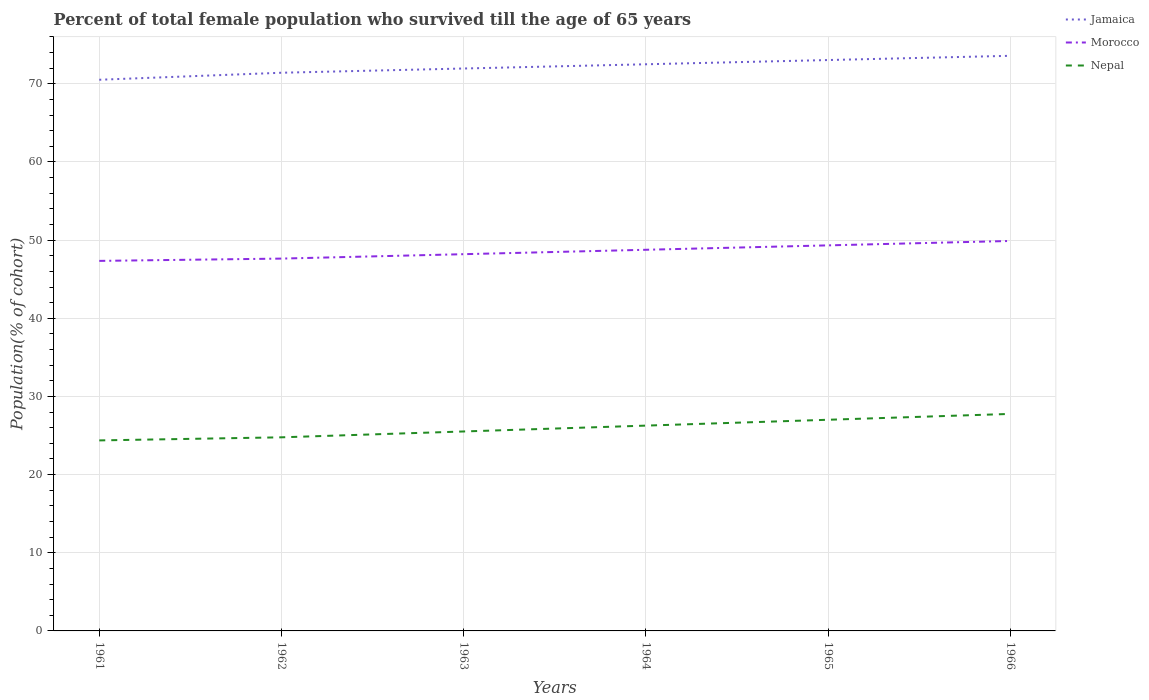How many different coloured lines are there?
Keep it short and to the point. 3. Across all years, what is the maximum percentage of total female population who survived till the age of 65 years in Jamaica?
Your answer should be compact. 70.52. What is the total percentage of total female population who survived till the age of 65 years in Nepal in the graph?
Your answer should be very brief. -0.75. What is the difference between the highest and the second highest percentage of total female population who survived till the age of 65 years in Jamaica?
Keep it short and to the point. 3.06. Is the percentage of total female population who survived till the age of 65 years in Nepal strictly greater than the percentage of total female population who survived till the age of 65 years in Morocco over the years?
Ensure brevity in your answer.  Yes. How many lines are there?
Offer a very short reply. 3. What is the difference between two consecutive major ticks on the Y-axis?
Ensure brevity in your answer.  10. Are the values on the major ticks of Y-axis written in scientific E-notation?
Your response must be concise. No. Does the graph contain any zero values?
Make the answer very short. No. Where does the legend appear in the graph?
Provide a short and direct response. Top right. What is the title of the graph?
Your answer should be very brief. Percent of total female population who survived till the age of 65 years. What is the label or title of the X-axis?
Your answer should be compact. Years. What is the label or title of the Y-axis?
Your answer should be very brief. Population(% of cohort). What is the Population(% of cohort) in Jamaica in 1961?
Give a very brief answer. 70.52. What is the Population(% of cohort) in Morocco in 1961?
Your response must be concise. 47.34. What is the Population(% of cohort) in Nepal in 1961?
Your response must be concise. 24.38. What is the Population(% of cohort) of Jamaica in 1962?
Ensure brevity in your answer.  71.42. What is the Population(% of cohort) of Morocco in 1962?
Offer a very short reply. 47.64. What is the Population(% of cohort) of Nepal in 1962?
Your answer should be compact. 24.77. What is the Population(% of cohort) in Jamaica in 1963?
Provide a short and direct response. 71.96. What is the Population(% of cohort) in Morocco in 1963?
Make the answer very short. 48.2. What is the Population(% of cohort) of Nepal in 1963?
Your answer should be very brief. 25.52. What is the Population(% of cohort) of Jamaica in 1964?
Provide a succinct answer. 72.5. What is the Population(% of cohort) in Morocco in 1964?
Offer a very short reply. 48.77. What is the Population(% of cohort) of Nepal in 1964?
Ensure brevity in your answer.  26.27. What is the Population(% of cohort) in Jamaica in 1965?
Ensure brevity in your answer.  73.04. What is the Population(% of cohort) in Morocco in 1965?
Offer a terse response. 49.33. What is the Population(% of cohort) in Nepal in 1965?
Provide a short and direct response. 27.02. What is the Population(% of cohort) in Jamaica in 1966?
Offer a very short reply. 73.59. What is the Population(% of cohort) of Morocco in 1966?
Provide a short and direct response. 49.9. What is the Population(% of cohort) of Nepal in 1966?
Make the answer very short. 27.77. Across all years, what is the maximum Population(% of cohort) in Jamaica?
Give a very brief answer. 73.59. Across all years, what is the maximum Population(% of cohort) in Morocco?
Offer a terse response. 49.9. Across all years, what is the maximum Population(% of cohort) of Nepal?
Keep it short and to the point. 27.77. Across all years, what is the minimum Population(% of cohort) in Jamaica?
Your answer should be compact. 70.52. Across all years, what is the minimum Population(% of cohort) of Morocco?
Make the answer very short. 47.34. Across all years, what is the minimum Population(% of cohort) in Nepal?
Provide a short and direct response. 24.38. What is the total Population(% of cohort) of Jamaica in the graph?
Provide a short and direct response. 433.03. What is the total Population(% of cohort) of Morocco in the graph?
Keep it short and to the point. 291.18. What is the total Population(% of cohort) in Nepal in the graph?
Your answer should be compact. 155.72. What is the difference between the Population(% of cohort) of Jamaica in 1961 and that in 1962?
Ensure brevity in your answer.  -0.9. What is the difference between the Population(% of cohort) in Morocco in 1961 and that in 1962?
Your answer should be very brief. -0.29. What is the difference between the Population(% of cohort) in Nepal in 1961 and that in 1962?
Your answer should be very brief. -0.39. What is the difference between the Population(% of cohort) of Jamaica in 1961 and that in 1963?
Your response must be concise. -1.44. What is the difference between the Population(% of cohort) of Morocco in 1961 and that in 1963?
Offer a very short reply. -0.86. What is the difference between the Population(% of cohort) in Nepal in 1961 and that in 1963?
Offer a very short reply. -1.14. What is the difference between the Population(% of cohort) in Jamaica in 1961 and that in 1964?
Provide a succinct answer. -1.98. What is the difference between the Population(% of cohort) of Morocco in 1961 and that in 1964?
Make the answer very short. -1.42. What is the difference between the Population(% of cohort) of Nepal in 1961 and that in 1964?
Ensure brevity in your answer.  -1.89. What is the difference between the Population(% of cohort) in Jamaica in 1961 and that in 1965?
Your answer should be very brief. -2.52. What is the difference between the Population(% of cohort) in Morocco in 1961 and that in 1965?
Offer a very short reply. -1.99. What is the difference between the Population(% of cohort) of Nepal in 1961 and that in 1965?
Give a very brief answer. -2.64. What is the difference between the Population(% of cohort) of Jamaica in 1961 and that in 1966?
Offer a terse response. -3.06. What is the difference between the Population(% of cohort) in Morocco in 1961 and that in 1966?
Offer a very short reply. -2.55. What is the difference between the Population(% of cohort) of Nepal in 1961 and that in 1966?
Offer a terse response. -3.39. What is the difference between the Population(% of cohort) of Jamaica in 1962 and that in 1963?
Your answer should be very brief. -0.54. What is the difference between the Population(% of cohort) of Morocco in 1962 and that in 1963?
Provide a short and direct response. -0.56. What is the difference between the Population(% of cohort) in Nepal in 1962 and that in 1963?
Your response must be concise. -0.75. What is the difference between the Population(% of cohort) of Jamaica in 1962 and that in 1964?
Your answer should be very brief. -1.08. What is the difference between the Population(% of cohort) of Morocco in 1962 and that in 1964?
Provide a short and direct response. -1.13. What is the difference between the Population(% of cohort) of Nepal in 1962 and that in 1964?
Make the answer very short. -1.5. What is the difference between the Population(% of cohort) of Jamaica in 1962 and that in 1965?
Offer a terse response. -1.63. What is the difference between the Population(% of cohort) of Morocco in 1962 and that in 1965?
Your answer should be very brief. -1.69. What is the difference between the Population(% of cohort) in Nepal in 1962 and that in 1965?
Provide a short and direct response. -2.25. What is the difference between the Population(% of cohort) in Jamaica in 1962 and that in 1966?
Offer a terse response. -2.17. What is the difference between the Population(% of cohort) of Morocco in 1962 and that in 1966?
Give a very brief answer. -2.26. What is the difference between the Population(% of cohort) in Nepal in 1962 and that in 1966?
Keep it short and to the point. -3. What is the difference between the Population(% of cohort) of Jamaica in 1963 and that in 1964?
Offer a very short reply. -0.54. What is the difference between the Population(% of cohort) of Morocco in 1963 and that in 1964?
Your answer should be very brief. -0.56. What is the difference between the Population(% of cohort) of Nepal in 1963 and that in 1964?
Provide a succinct answer. -0.75. What is the difference between the Population(% of cohort) in Jamaica in 1963 and that in 1965?
Provide a succinct answer. -1.08. What is the difference between the Population(% of cohort) of Morocco in 1963 and that in 1965?
Offer a very short reply. -1.13. What is the difference between the Population(% of cohort) of Nepal in 1963 and that in 1965?
Keep it short and to the point. -1.5. What is the difference between the Population(% of cohort) of Jamaica in 1963 and that in 1966?
Offer a terse response. -1.63. What is the difference between the Population(% of cohort) of Morocco in 1963 and that in 1966?
Give a very brief answer. -1.69. What is the difference between the Population(% of cohort) of Nepal in 1963 and that in 1966?
Your response must be concise. -2.25. What is the difference between the Population(% of cohort) in Jamaica in 1964 and that in 1965?
Keep it short and to the point. -0.54. What is the difference between the Population(% of cohort) in Morocco in 1964 and that in 1965?
Provide a succinct answer. -0.56. What is the difference between the Population(% of cohort) of Nepal in 1964 and that in 1965?
Offer a terse response. -0.75. What is the difference between the Population(% of cohort) in Jamaica in 1964 and that in 1966?
Give a very brief answer. -1.08. What is the difference between the Population(% of cohort) of Morocco in 1964 and that in 1966?
Your answer should be very brief. -1.13. What is the difference between the Population(% of cohort) of Nepal in 1964 and that in 1966?
Provide a succinct answer. -1.5. What is the difference between the Population(% of cohort) in Jamaica in 1965 and that in 1966?
Give a very brief answer. -0.54. What is the difference between the Population(% of cohort) of Morocco in 1965 and that in 1966?
Give a very brief answer. -0.56. What is the difference between the Population(% of cohort) in Nepal in 1965 and that in 1966?
Give a very brief answer. -0.75. What is the difference between the Population(% of cohort) of Jamaica in 1961 and the Population(% of cohort) of Morocco in 1962?
Your answer should be compact. 22.88. What is the difference between the Population(% of cohort) in Jamaica in 1961 and the Population(% of cohort) in Nepal in 1962?
Provide a succinct answer. 45.75. What is the difference between the Population(% of cohort) in Morocco in 1961 and the Population(% of cohort) in Nepal in 1962?
Provide a short and direct response. 22.57. What is the difference between the Population(% of cohort) of Jamaica in 1961 and the Population(% of cohort) of Morocco in 1963?
Keep it short and to the point. 22.32. What is the difference between the Population(% of cohort) in Jamaica in 1961 and the Population(% of cohort) in Nepal in 1963?
Keep it short and to the point. 45. What is the difference between the Population(% of cohort) in Morocco in 1961 and the Population(% of cohort) in Nepal in 1963?
Offer a very short reply. 21.82. What is the difference between the Population(% of cohort) in Jamaica in 1961 and the Population(% of cohort) in Morocco in 1964?
Give a very brief answer. 21.75. What is the difference between the Population(% of cohort) in Jamaica in 1961 and the Population(% of cohort) in Nepal in 1964?
Your answer should be compact. 44.25. What is the difference between the Population(% of cohort) in Morocco in 1961 and the Population(% of cohort) in Nepal in 1964?
Give a very brief answer. 21.08. What is the difference between the Population(% of cohort) in Jamaica in 1961 and the Population(% of cohort) in Morocco in 1965?
Your answer should be very brief. 21.19. What is the difference between the Population(% of cohort) in Jamaica in 1961 and the Population(% of cohort) in Nepal in 1965?
Your answer should be very brief. 43.5. What is the difference between the Population(% of cohort) in Morocco in 1961 and the Population(% of cohort) in Nepal in 1965?
Your response must be concise. 20.33. What is the difference between the Population(% of cohort) of Jamaica in 1961 and the Population(% of cohort) of Morocco in 1966?
Your answer should be very brief. 20.63. What is the difference between the Population(% of cohort) in Jamaica in 1961 and the Population(% of cohort) in Nepal in 1966?
Ensure brevity in your answer.  42.75. What is the difference between the Population(% of cohort) of Morocco in 1961 and the Population(% of cohort) of Nepal in 1966?
Ensure brevity in your answer.  19.58. What is the difference between the Population(% of cohort) of Jamaica in 1962 and the Population(% of cohort) of Morocco in 1963?
Keep it short and to the point. 23.21. What is the difference between the Population(% of cohort) of Jamaica in 1962 and the Population(% of cohort) of Nepal in 1963?
Provide a succinct answer. 45.9. What is the difference between the Population(% of cohort) in Morocco in 1962 and the Population(% of cohort) in Nepal in 1963?
Your response must be concise. 22.12. What is the difference between the Population(% of cohort) in Jamaica in 1962 and the Population(% of cohort) in Morocco in 1964?
Your answer should be very brief. 22.65. What is the difference between the Population(% of cohort) of Jamaica in 1962 and the Population(% of cohort) of Nepal in 1964?
Your response must be concise. 45.15. What is the difference between the Population(% of cohort) of Morocco in 1962 and the Population(% of cohort) of Nepal in 1964?
Provide a succinct answer. 21.37. What is the difference between the Population(% of cohort) in Jamaica in 1962 and the Population(% of cohort) in Morocco in 1965?
Provide a succinct answer. 22.09. What is the difference between the Population(% of cohort) of Jamaica in 1962 and the Population(% of cohort) of Nepal in 1965?
Ensure brevity in your answer.  44.4. What is the difference between the Population(% of cohort) of Morocco in 1962 and the Population(% of cohort) of Nepal in 1965?
Give a very brief answer. 20.62. What is the difference between the Population(% of cohort) in Jamaica in 1962 and the Population(% of cohort) in Morocco in 1966?
Offer a very short reply. 21.52. What is the difference between the Population(% of cohort) of Jamaica in 1962 and the Population(% of cohort) of Nepal in 1966?
Ensure brevity in your answer.  43.65. What is the difference between the Population(% of cohort) of Morocco in 1962 and the Population(% of cohort) of Nepal in 1966?
Provide a succinct answer. 19.87. What is the difference between the Population(% of cohort) in Jamaica in 1963 and the Population(% of cohort) in Morocco in 1964?
Offer a terse response. 23.19. What is the difference between the Population(% of cohort) in Jamaica in 1963 and the Population(% of cohort) in Nepal in 1964?
Ensure brevity in your answer.  45.69. What is the difference between the Population(% of cohort) of Morocco in 1963 and the Population(% of cohort) of Nepal in 1964?
Give a very brief answer. 21.93. What is the difference between the Population(% of cohort) of Jamaica in 1963 and the Population(% of cohort) of Morocco in 1965?
Keep it short and to the point. 22.63. What is the difference between the Population(% of cohort) of Jamaica in 1963 and the Population(% of cohort) of Nepal in 1965?
Offer a terse response. 44.94. What is the difference between the Population(% of cohort) of Morocco in 1963 and the Population(% of cohort) of Nepal in 1965?
Provide a succinct answer. 21.19. What is the difference between the Population(% of cohort) in Jamaica in 1963 and the Population(% of cohort) in Morocco in 1966?
Offer a very short reply. 22.07. What is the difference between the Population(% of cohort) of Jamaica in 1963 and the Population(% of cohort) of Nepal in 1966?
Offer a very short reply. 44.19. What is the difference between the Population(% of cohort) in Morocco in 1963 and the Population(% of cohort) in Nepal in 1966?
Your answer should be very brief. 20.44. What is the difference between the Population(% of cohort) in Jamaica in 1964 and the Population(% of cohort) in Morocco in 1965?
Your answer should be compact. 23.17. What is the difference between the Population(% of cohort) of Jamaica in 1964 and the Population(% of cohort) of Nepal in 1965?
Make the answer very short. 45.48. What is the difference between the Population(% of cohort) of Morocco in 1964 and the Population(% of cohort) of Nepal in 1965?
Give a very brief answer. 21.75. What is the difference between the Population(% of cohort) of Jamaica in 1964 and the Population(% of cohort) of Morocco in 1966?
Keep it short and to the point. 22.61. What is the difference between the Population(% of cohort) of Jamaica in 1964 and the Population(% of cohort) of Nepal in 1966?
Give a very brief answer. 44.74. What is the difference between the Population(% of cohort) in Morocco in 1964 and the Population(% of cohort) in Nepal in 1966?
Make the answer very short. 21. What is the difference between the Population(% of cohort) of Jamaica in 1965 and the Population(% of cohort) of Morocco in 1966?
Your answer should be very brief. 23.15. What is the difference between the Population(% of cohort) in Jamaica in 1965 and the Population(% of cohort) in Nepal in 1966?
Your answer should be compact. 45.28. What is the difference between the Population(% of cohort) of Morocco in 1965 and the Population(% of cohort) of Nepal in 1966?
Make the answer very short. 21.57. What is the average Population(% of cohort) of Jamaica per year?
Give a very brief answer. 72.17. What is the average Population(% of cohort) of Morocco per year?
Your answer should be compact. 48.53. What is the average Population(% of cohort) in Nepal per year?
Your response must be concise. 25.95. In the year 1961, what is the difference between the Population(% of cohort) of Jamaica and Population(% of cohort) of Morocco?
Provide a short and direct response. 23.18. In the year 1961, what is the difference between the Population(% of cohort) of Jamaica and Population(% of cohort) of Nepal?
Make the answer very short. 46.14. In the year 1961, what is the difference between the Population(% of cohort) of Morocco and Population(% of cohort) of Nepal?
Your response must be concise. 22.97. In the year 1962, what is the difference between the Population(% of cohort) of Jamaica and Population(% of cohort) of Morocco?
Provide a succinct answer. 23.78. In the year 1962, what is the difference between the Population(% of cohort) in Jamaica and Population(% of cohort) in Nepal?
Keep it short and to the point. 46.65. In the year 1962, what is the difference between the Population(% of cohort) in Morocco and Population(% of cohort) in Nepal?
Your response must be concise. 22.87. In the year 1963, what is the difference between the Population(% of cohort) of Jamaica and Population(% of cohort) of Morocco?
Your answer should be very brief. 23.76. In the year 1963, what is the difference between the Population(% of cohort) in Jamaica and Population(% of cohort) in Nepal?
Offer a terse response. 46.44. In the year 1963, what is the difference between the Population(% of cohort) of Morocco and Population(% of cohort) of Nepal?
Provide a succinct answer. 22.68. In the year 1964, what is the difference between the Population(% of cohort) of Jamaica and Population(% of cohort) of Morocco?
Provide a succinct answer. 23.73. In the year 1964, what is the difference between the Population(% of cohort) of Jamaica and Population(% of cohort) of Nepal?
Your answer should be very brief. 46.23. In the year 1964, what is the difference between the Population(% of cohort) of Morocco and Population(% of cohort) of Nepal?
Provide a short and direct response. 22.5. In the year 1965, what is the difference between the Population(% of cohort) of Jamaica and Population(% of cohort) of Morocco?
Make the answer very short. 23.71. In the year 1965, what is the difference between the Population(% of cohort) of Jamaica and Population(% of cohort) of Nepal?
Your answer should be compact. 46.03. In the year 1965, what is the difference between the Population(% of cohort) of Morocco and Population(% of cohort) of Nepal?
Provide a succinct answer. 22.31. In the year 1966, what is the difference between the Population(% of cohort) in Jamaica and Population(% of cohort) in Morocco?
Offer a terse response. 23.69. In the year 1966, what is the difference between the Population(% of cohort) of Jamaica and Population(% of cohort) of Nepal?
Your response must be concise. 45.82. In the year 1966, what is the difference between the Population(% of cohort) in Morocco and Population(% of cohort) in Nepal?
Provide a succinct answer. 22.13. What is the ratio of the Population(% of cohort) of Jamaica in 1961 to that in 1962?
Offer a terse response. 0.99. What is the ratio of the Population(% of cohort) in Morocco in 1961 to that in 1962?
Provide a short and direct response. 0.99. What is the ratio of the Population(% of cohort) in Nepal in 1961 to that in 1962?
Make the answer very short. 0.98. What is the ratio of the Population(% of cohort) in Jamaica in 1961 to that in 1963?
Your answer should be very brief. 0.98. What is the ratio of the Population(% of cohort) of Morocco in 1961 to that in 1963?
Provide a short and direct response. 0.98. What is the ratio of the Population(% of cohort) in Nepal in 1961 to that in 1963?
Give a very brief answer. 0.96. What is the ratio of the Population(% of cohort) of Jamaica in 1961 to that in 1964?
Your answer should be compact. 0.97. What is the ratio of the Population(% of cohort) in Morocco in 1961 to that in 1964?
Provide a succinct answer. 0.97. What is the ratio of the Population(% of cohort) in Nepal in 1961 to that in 1964?
Your answer should be compact. 0.93. What is the ratio of the Population(% of cohort) of Jamaica in 1961 to that in 1965?
Make the answer very short. 0.97. What is the ratio of the Population(% of cohort) of Morocco in 1961 to that in 1965?
Your answer should be compact. 0.96. What is the ratio of the Population(% of cohort) in Nepal in 1961 to that in 1965?
Make the answer very short. 0.9. What is the ratio of the Population(% of cohort) in Jamaica in 1961 to that in 1966?
Your response must be concise. 0.96. What is the ratio of the Population(% of cohort) in Morocco in 1961 to that in 1966?
Give a very brief answer. 0.95. What is the ratio of the Population(% of cohort) of Nepal in 1961 to that in 1966?
Your response must be concise. 0.88. What is the ratio of the Population(% of cohort) in Morocco in 1962 to that in 1963?
Your answer should be compact. 0.99. What is the ratio of the Population(% of cohort) in Nepal in 1962 to that in 1963?
Your answer should be compact. 0.97. What is the ratio of the Population(% of cohort) in Jamaica in 1962 to that in 1964?
Make the answer very short. 0.99. What is the ratio of the Population(% of cohort) in Morocco in 1962 to that in 1964?
Make the answer very short. 0.98. What is the ratio of the Population(% of cohort) in Nepal in 1962 to that in 1964?
Offer a very short reply. 0.94. What is the ratio of the Population(% of cohort) of Jamaica in 1962 to that in 1965?
Give a very brief answer. 0.98. What is the ratio of the Population(% of cohort) in Morocco in 1962 to that in 1965?
Your answer should be compact. 0.97. What is the ratio of the Population(% of cohort) in Nepal in 1962 to that in 1965?
Offer a terse response. 0.92. What is the ratio of the Population(% of cohort) of Jamaica in 1962 to that in 1966?
Your response must be concise. 0.97. What is the ratio of the Population(% of cohort) in Morocco in 1962 to that in 1966?
Your answer should be very brief. 0.95. What is the ratio of the Population(% of cohort) in Nepal in 1962 to that in 1966?
Your answer should be very brief. 0.89. What is the ratio of the Population(% of cohort) of Morocco in 1963 to that in 1964?
Offer a very short reply. 0.99. What is the ratio of the Population(% of cohort) in Nepal in 1963 to that in 1964?
Ensure brevity in your answer.  0.97. What is the ratio of the Population(% of cohort) of Jamaica in 1963 to that in 1965?
Your answer should be compact. 0.99. What is the ratio of the Population(% of cohort) of Morocco in 1963 to that in 1965?
Offer a terse response. 0.98. What is the ratio of the Population(% of cohort) in Nepal in 1963 to that in 1965?
Your response must be concise. 0.94. What is the ratio of the Population(% of cohort) in Jamaica in 1963 to that in 1966?
Your answer should be very brief. 0.98. What is the ratio of the Population(% of cohort) in Morocco in 1963 to that in 1966?
Make the answer very short. 0.97. What is the ratio of the Population(% of cohort) in Nepal in 1963 to that in 1966?
Offer a terse response. 0.92. What is the ratio of the Population(% of cohort) of Morocco in 1964 to that in 1965?
Your response must be concise. 0.99. What is the ratio of the Population(% of cohort) of Nepal in 1964 to that in 1965?
Give a very brief answer. 0.97. What is the ratio of the Population(% of cohort) in Morocco in 1964 to that in 1966?
Your answer should be very brief. 0.98. What is the ratio of the Population(% of cohort) of Nepal in 1964 to that in 1966?
Offer a very short reply. 0.95. What is the ratio of the Population(% of cohort) in Jamaica in 1965 to that in 1966?
Offer a terse response. 0.99. What is the ratio of the Population(% of cohort) of Morocco in 1965 to that in 1966?
Offer a terse response. 0.99. What is the difference between the highest and the second highest Population(% of cohort) in Jamaica?
Offer a very short reply. 0.54. What is the difference between the highest and the second highest Population(% of cohort) in Morocco?
Ensure brevity in your answer.  0.56. What is the difference between the highest and the second highest Population(% of cohort) in Nepal?
Provide a short and direct response. 0.75. What is the difference between the highest and the lowest Population(% of cohort) in Jamaica?
Your answer should be compact. 3.06. What is the difference between the highest and the lowest Population(% of cohort) in Morocco?
Offer a very short reply. 2.55. What is the difference between the highest and the lowest Population(% of cohort) of Nepal?
Keep it short and to the point. 3.39. 